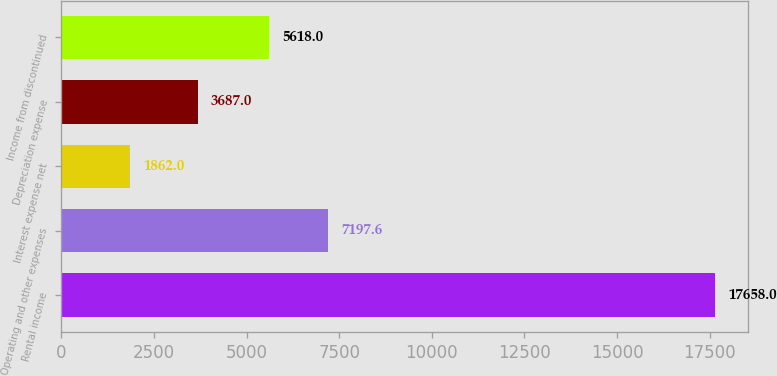Convert chart to OTSL. <chart><loc_0><loc_0><loc_500><loc_500><bar_chart><fcel>Rental income<fcel>Operating and other expenses<fcel>Interest expense net<fcel>Depreciation expense<fcel>Income from discontinued<nl><fcel>17658<fcel>7197.6<fcel>1862<fcel>3687<fcel>5618<nl></chart> 